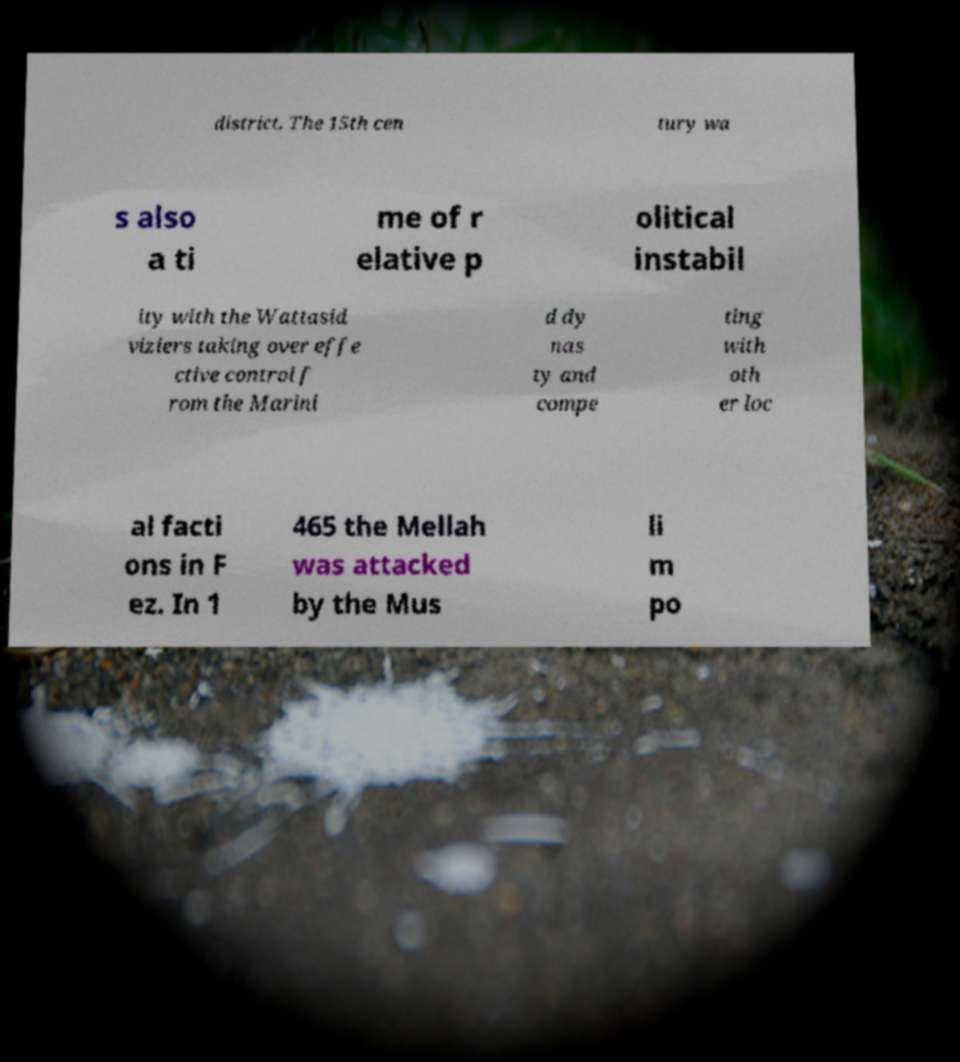Could you assist in decoding the text presented in this image and type it out clearly? district. The 15th cen tury wa s also a ti me of r elative p olitical instabil ity with the Wattasid viziers taking over effe ctive control f rom the Marini d dy nas ty and compe ting with oth er loc al facti ons in F ez. In 1 465 the Mellah was attacked by the Mus li m po 